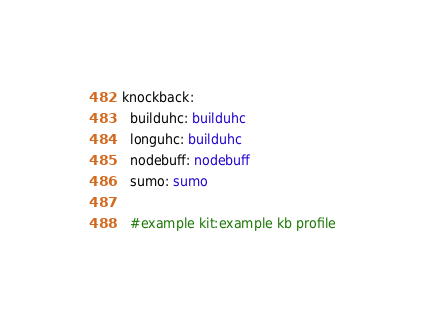Convert code to text. <code><loc_0><loc_0><loc_500><loc_500><_YAML_>knockback:
  builduhc: builduhc
  longuhc: builduhc
  nodebuff: nodebuff
  sumo: sumo

  #example kit:example kb profile
</code> 